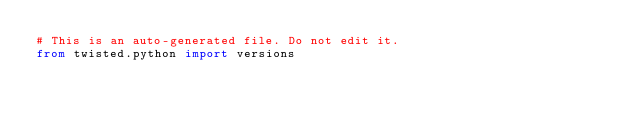<code> <loc_0><loc_0><loc_500><loc_500><_Python_># This is an auto-generated file. Do not edit it.
from twisted.python import versions</code> 